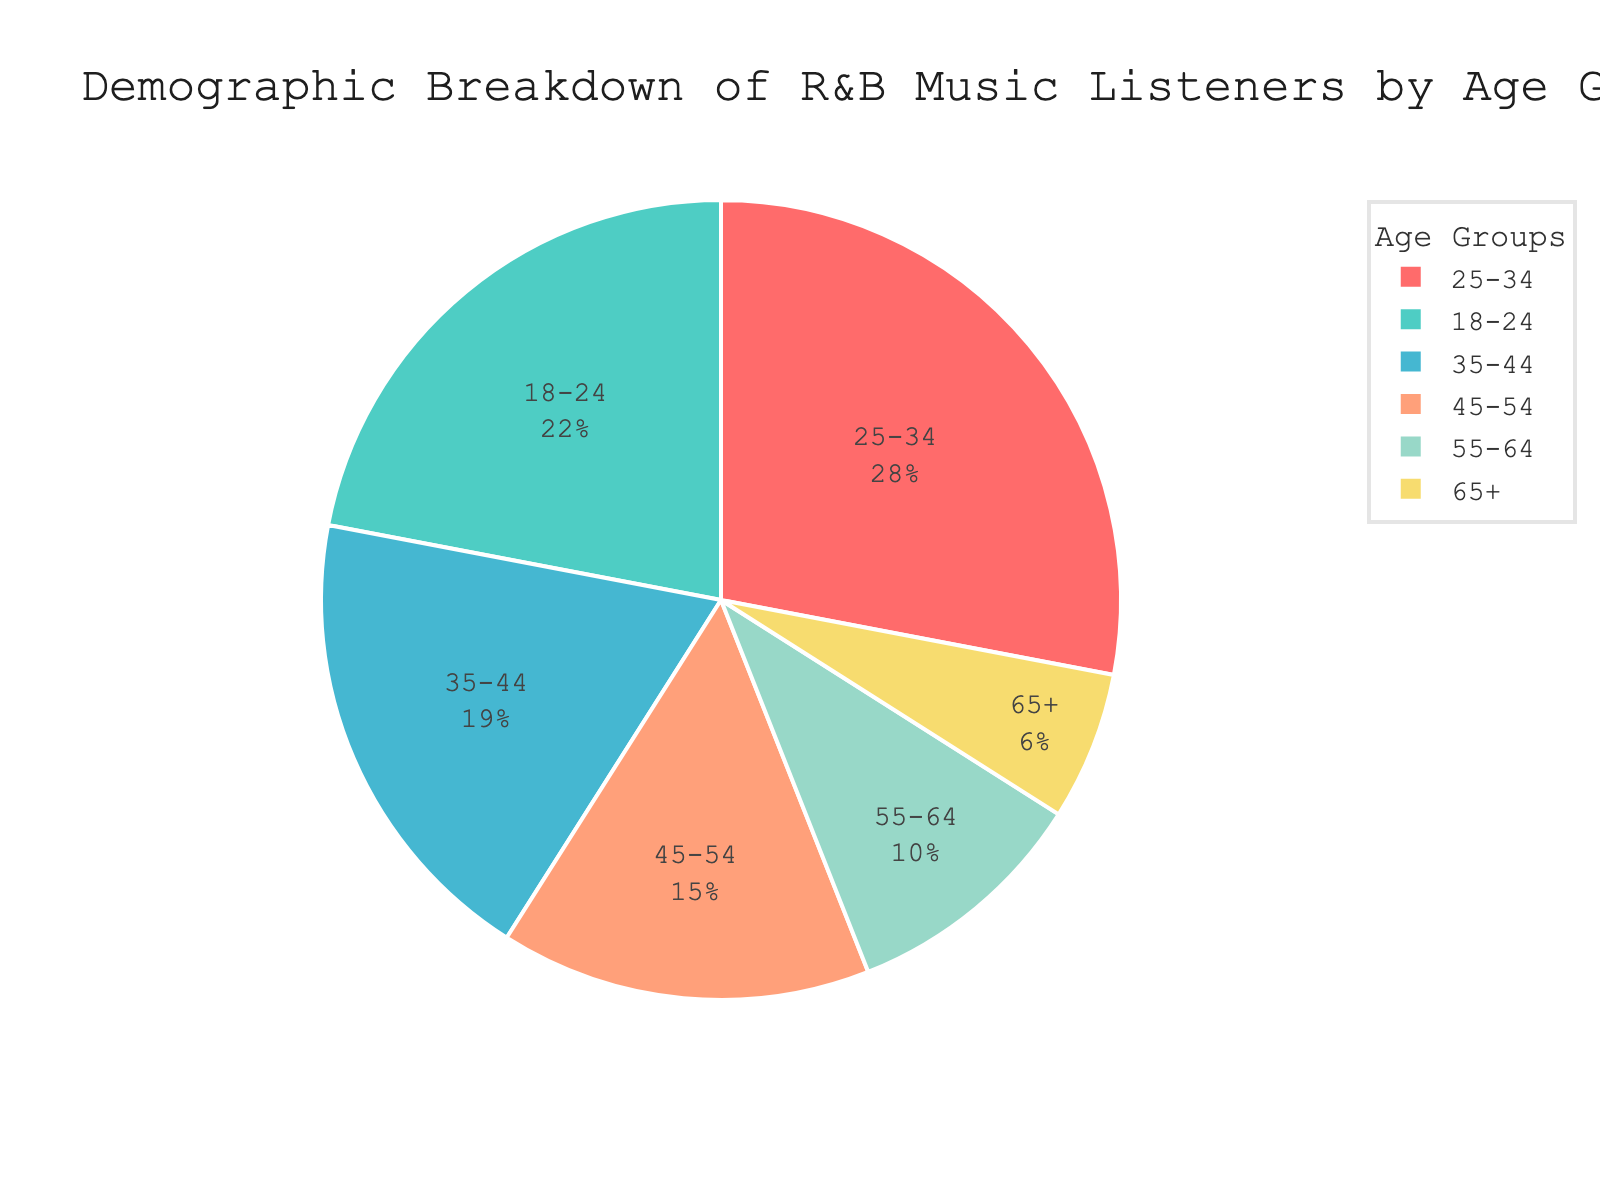What's the largest age group of R&B music listeners? The pie chart shows that the 25-34 age group has the highest percentage of listeners at 28%.
Answer: 25-34 Which age group constitutes the combined smallest percentage? By summing the percentages of the two smallest segments, 55-64 (10%) and 65+ (6%), the combined smallest percentage is 16%.
Answer: 55-64 and 65+ How much larger is the listener percentage for the 18-24 age group compared to the 65+ age group? The 18-24 age group has a percentage of 22%, while the 65+ age group has 6%. The difference is calculated as 22% - 6% = 16%.
Answer: 16% How do the combined percentages of listeners aged 35-44 and 45-54 compare to the 25-34 age group alone? Adding the percentages of 35-44 (19%) and 45-54 (15%) gives a total of 34%, which is higher than the 25-34 age group at 28%.
Answer: Higher by 6% What is the percentage of listeners in age groups younger than 35? Adding the percentages of the 18-24 group (22%) and 25-34 group (28%) gives a combined percentage of 50%.
Answer: 50% What is the difference between the percentages of the age groups 35-44 and 55-64? The percentage for 35-44 is 19%, and for 55-64, it is 10%. The difference is calculated as 19% - 10% = 9%.
Answer: 9% Which color represents the 55-64 age group in the chart? The pie chart uses specific colors to represent different age groups, with the 55-64 age group shown in a greenish hue.
Answer: Greenish Are there more listeners aged 45-54 or listeners aged 65+? Based on the pie chart, the percentage for 45-54 is 15%, which is higher than the 6% for the 65+ age group.
Answer: 45-54 What is the total percentage of listeners aged 35 and above? Adding the percentages for age groups 35-44 (19%), 45-54 (15%), 55-64 (10%), and 65+ (6%) results in a combined total of 50%.
Answer: 50% 